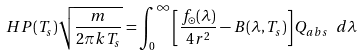Convert formula to latex. <formula><loc_0><loc_0><loc_500><loc_500>H P ( T _ { s } ) \sqrt { \frac { m } { 2 \pi k T _ { s } } } = \int _ { 0 } ^ { \infty } \left [ \frac { f _ { \odot } ( \lambda ) } { 4 r ^ { 2 } } - B ( \lambda , T _ { s } ) \right ] Q _ { a b s } \ d \lambda</formula> 